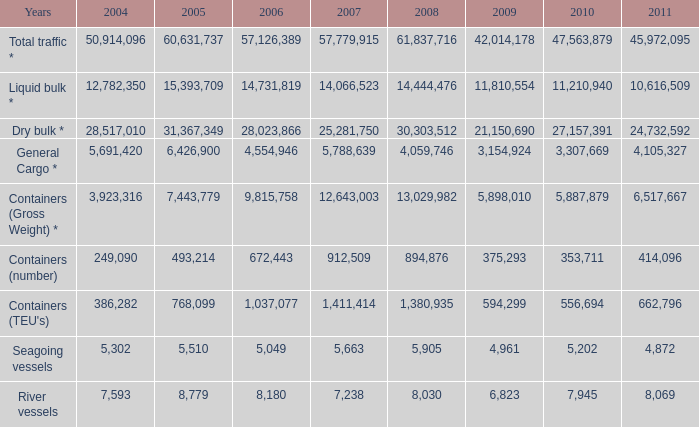What is the greatest number in 2011 with fewer than 5,049 in 2006 and less than 1,380,935 in 2008? None. 